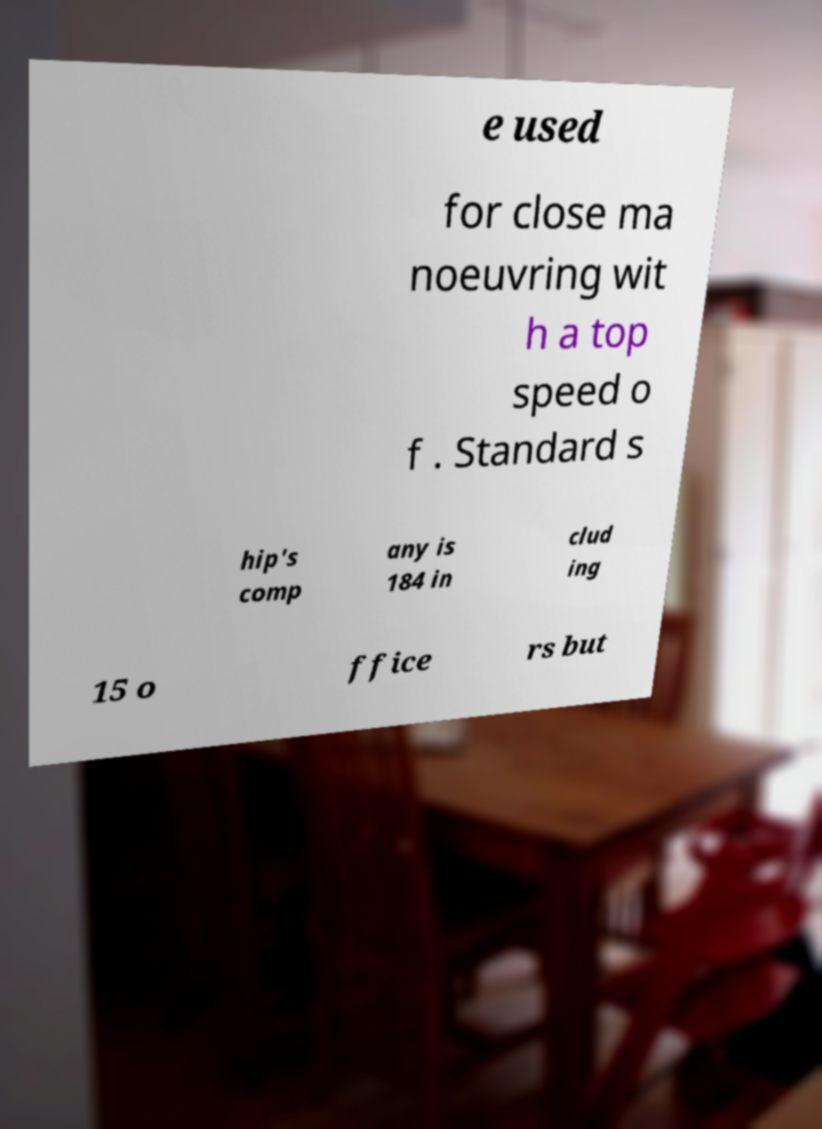Could you extract and type out the text from this image? e used for close ma noeuvring wit h a top speed o f . Standard s hip's comp any is 184 in clud ing 15 o ffice rs but 